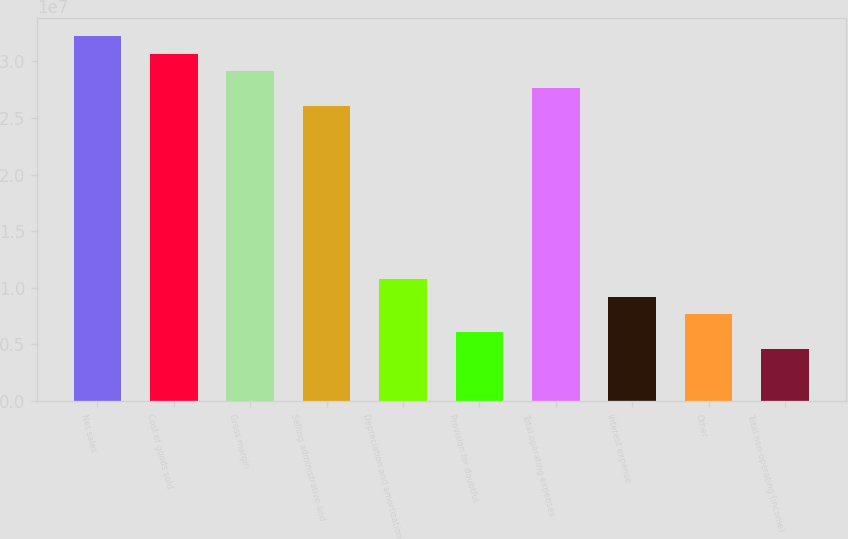Convert chart. <chart><loc_0><loc_0><loc_500><loc_500><bar_chart><fcel>Net sales<fcel>Cost of goods sold<fcel>Gross margin<fcel>Selling administrative and<fcel>Depreciation and amortization<fcel>Provision for doubtful<fcel>Total operating expenses<fcel>Interest expense<fcel>Other<fcel>Total non-operating (income)<nl><fcel>3.22175e+07<fcel>3.06833e+07<fcel>2.91491e+07<fcel>2.60808e+07<fcel>1.07392e+07<fcel>6.13666e+06<fcel>2.7615e+07<fcel>9.20499e+06<fcel>7.67083e+06<fcel>4.6025e+06<nl></chart> 